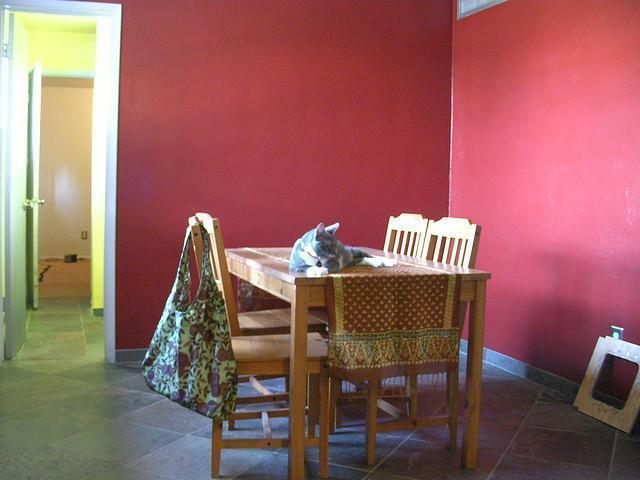What is the cat on top of?
Select the accurate response from the four choices given to answer the question.
Options: Basket, cardboard box, table, human tummy. Table. 